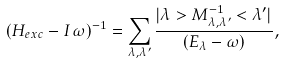<formula> <loc_0><loc_0><loc_500><loc_500>( H _ { e x c } - I \, \omega ) ^ { - 1 } = \sum _ { \lambda , \lambda ^ { \prime } } \frac { | \lambda > M _ { \lambda , \lambda ^ { \prime } } ^ { - 1 } < \lambda ^ { \prime } | } { ( E _ { \lambda } - \omega ) } ,</formula> 